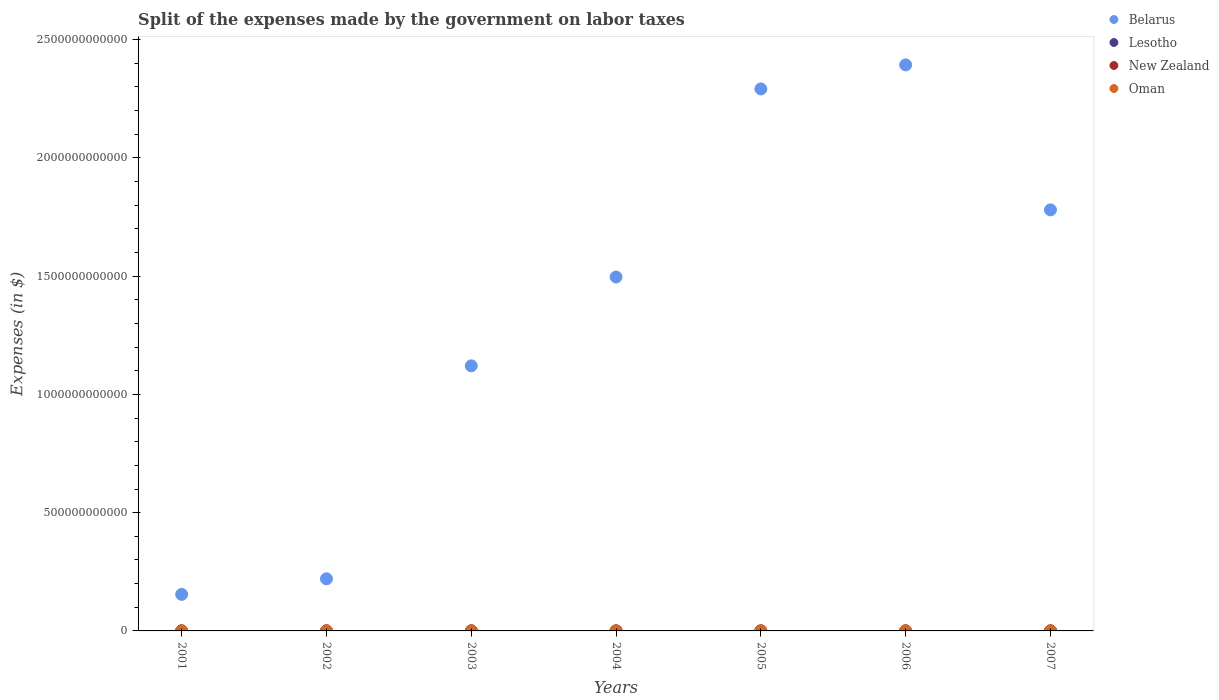How many different coloured dotlines are there?
Provide a short and direct response. 4. What is the expenses made by the government on labor taxes in Oman in 2005?
Provide a succinct answer. 7.12e+07. Across all years, what is the maximum expenses made by the government on labor taxes in Belarus?
Give a very brief answer. 2.39e+12. Across all years, what is the minimum expenses made by the government on labor taxes in Oman?
Your answer should be very brief. 3.87e+07. In which year was the expenses made by the government on labor taxes in New Zealand maximum?
Provide a short and direct response. 2006. In which year was the expenses made by the government on labor taxes in Belarus minimum?
Ensure brevity in your answer.  2001. What is the total expenses made by the government on labor taxes in Belarus in the graph?
Make the answer very short. 9.46e+12. What is the difference between the expenses made by the government on labor taxes in New Zealand in 2002 and that in 2004?
Give a very brief answer. -1.04e+06. What is the difference between the expenses made by the government on labor taxes in New Zealand in 2006 and the expenses made by the government on labor taxes in Lesotho in 2004?
Ensure brevity in your answer.  -1.48e+07. What is the average expenses made by the government on labor taxes in Oman per year?
Provide a short and direct response. 5.87e+07. In the year 2003, what is the difference between the expenses made by the government on labor taxes in Oman and expenses made by the government on labor taxes in Belarus?
Your response must be concise. -1.12e+12. What is the ratio of the expenses made by the government on labor taxes in Belarus in 2001 to that in 2007?
Your answer should be very brief. 0.09. Is the expenses made by the government on labor taxes in Belarus in 2001 less than that in 2004?
Provide a succinct answer. Yes. What is the difference between the highest and the second highest expenses made by the government on labor taxes in New Zealand?
Your answer should be very brief. 6.51e+05. What is the difference between the highest and the lowest expenses made by the government on labor taxes in Belarus?
Your answer should be very brief. 2.24e+12. In how many years, is the expenses made by the government on labor taxes in New Zealand greater than the average expenses made by the government on labor taxes in New Zealand taken over all years?
Provide a succinct answer. 3. Is it the case that in every year, the sum of the expenses made by the government on labor taxes in Belarus and expenses made by the government on labor taxes in New Zealand  is greater than the sum of expenses made by the government on labor taxes in Lesotho and expenses made by the government on labor taxes in Oman?
Offer a terse response. No. Is it the case that in every year, the sum of the expenses made by the government on labor taxes in Lesotho and expenses made by the government on labor taxes in Belarus  is greater than the expenses made by the government on labor taxes in New Zealand?
Make the answer very short. Yes. How many years are there in the graph?
Provide a short and direct response. 7. What is the difference between two consecutive major ticks on the Y-axis?
Offer a very short reply. 5.00e+11. Does the graph contain any zero values?
Make the answer very short. No. Does the graph contain grids?
Your response must be concise. No. What is the title of the graph?
Your answer should be very brief. Split of the expenses made by the government on labor taxes. What is the label or title of the X-axis?
Keep it short and to the point. Years. What is the label or title of the Y-axis?
Make the answer very short. Expenses (in $). What is the Expenses (in $) of Belarus in 2001?
Offer a terse response. 1.55e+11. What is the Expenses (in $) in Lesotho in 2001?
Your answer should be very brief. 5.30e+06. What is the Expenses (in $) in New Zealand in 2001?
Offer a terse response. 1.80e+06. What is the Expenses (in $) in Oman in 2001?
Offer a terse response. 3.87e+07. What is the Expenses (in $) of Belarus in 2002?
Offer a very short reply. 2.20e+11. What is the Expenses (in $) of Lesotho in 2002?
Make the answer very short. 6.40e+06. What is the Expenses (in $) in New Zealand in 2002?
Offer a terse response. 1.31e+06. What is the Expenses (in $) of Oman in 2002?
Provide a succinct answer. 3.98e+07. What is the Expenses (in $) of Belarus in 2003?
Your response must be concise. 1.12e+12. What is the Expenses (in $) of Lesotho in 2003?
Offer a very short reply. 1.05e+07. What is the Expenses (in $) in New Zealand in 2003?
Your answer should be compact. 1.36e+06. What is the Expenses (in $) in Oman in 2003?
Make the answer very short. 4.31e+07. What is the Expenses (in $) in Belarus in 2004?
Offer a terse response. 1.50e+12. What is the Expenses (in $) of Lesotho in 2004?
Provide a short and direct response. 1.78e+07. What is the Expenses (in $) of New Zealand in 2004?
Make the answer very short. 2.35e+06. What is the Expenses (in $) of Oman in 2004?
Offer a very short reply. 4.91e+07. What is the Expenses (in $) of Belarus in 2005?
Give a very brief answer. 2.29e+12. What is the Expenses (in $) in Lesotho in 2005?
Keep it short and to the point. 6.74e+06. What is the Expenses (in $) in New Zealand in 2005?
Offer a very short reply. 2.32e+06. What is the Expenses (in $) of Oman in 2005?
Your response must be concise. 7.12e+07. What is the Expenses (in $) of Belarus in 2006?
Keep it short and to the point. 2.39e+12. What is the Expenses (in $) in Lesotho in 2006?
Make the answer very short. 7.48e+07. What is the Expenses (in $) in Oman in 2006?
Provide a short and direct response. 7.82e+07. What is the Expenses (in $) in Belarus in 2007?
Ensure brevity in your answer.  1.78e+12. What is the Expenses (in $) in Lesotho in 2007?
Provide a short and direct response. 6.62e+06. What is the Expenses (in $) in Oman in 2007?
Offer a terse response. 9.09e+07. Across all years, what is the maximum Expenses (in $) of Belarus?
Provide a succinct answer. 2.39e+12. Across all years, what is the maximum Expenses (in $) of Lesotho?
Your answer should be compact. 7.48e+07. Across all years, what is the maximum Expenses (in $) in Oman?
Offer a very short reply. 9.09e+07. Across all years, what is the minimum Expenses (in $) in Belarus?
Make the answer very short. 1.55e+11. Across all years, what is the minimum Expenses (in $) in Lesotho?
Provide a succinct answer. 5.30e+06. Across all years, what is the minimum Expenses (in $) of New Zealand?
Offer a terse response. 1.31e+06. Across all years, what is the minimum Expenses (in $) in Oman?
Make the answer very short. 3.87e+07. What is the total Expenses (in $) of Belarus in the graph?
Offer a terse response. 9.46e+12. What is the total Expenses (in $) in Lesotho in the graph?
Your answer should be very brief. 1.28e+08. What is the total Expenses (in $) in New Zealand in the graph?
Keep it short and to the point. 1.41e+07. What is the total Expenses (in $) of Oman in the graph?
Offer a terse response. 4.11e+08. What is the difference between the Expenses (in $) in Belarus in 2001 and that in 2002?
Your response must be concise. -6.58e+1. What is the difference between the Expenses (in $) of Lesotho in 2001 and that in 2002?
Give a very brief answer. -1.10e+06. What is the difference between the Expenses (in $) of New Zealand in 2001 and that in 2002?
Keep it short and to the point. 4.87e+05. What is the difference between the Expenses (in $) of Oman in 2001 and that in 2002?
Provide a succinct answer. -1.10e+06. What is the difference between the Expenses (in $) of Belarus in 2001 and that in 2003?
Your answer should be very brief. -9.66e+11. What is the difference between the Expenses (in $) of Lesotho in 2001 and that in 2003?
Offer a very short reply. -5.18e+06. What is the difference between the Expenses (in $) in New Zealand in 2001 and that in 2003?
Provide a succinct answer. 4.44e+05. What is the difference between the Expenses (in $) of Oman in 2001 and that in 2003?
Your answer should be compact. -4.40e+06. What is the difference between the Expenses (in $) in Belarus in 2001 and that in 2004?
Your response must be concise. -1.34e+12. What is the difference between the Expenses (in $) of Lesotho in 2001 and that in 2004?
Your answer should be very brief. -1.25e+07. What is the difference between the Expenses (in $) of New Zealand in 2001 and that in 2004?
Offer a very short reply. -5.49e+05. What is the difference between the Expenses (in $) in Oman in 2001 and that in 2004?
Provide a succinct answer. -1.04e+07. What is the difference between the Expenses (in $) in Belarus in 2001 and that in 2005?
Your response must be concise. -2.14e+12. What is the difference between the Expenses (in $) of Lesotho in 2001 and that in 2005?
Keep it short and to the point. -1.44e+06. What is the difference between the Expenses (in $) in New Zealand in 2001 and that in 2005?
Provide a short and direct response. -5.25e+05. What is the difference between the Expenses (in $) of Oman in 2001 and that in 2005?
Your answer should be compact. -3.25e+07. What is the difference between the Expenses (in $) of Belarus in 2001 and that in 2006?
Offer a terse response. -2.24e+12. What is the difference between the Expenses (in $) of Lesotho in 2001 and that in 2006?
Your answer should be compact. -6.95e+07. What is the difference between the Expenses (in $) of New Zealand in 2001 and that in 2006?
Provide a short and direct response. -1.20e+06. What is the difference between the Expenses (in $) in Oman in 2001 and that in 2006?
Offer a very short reply. -3.95e+07. What is the difference between the Expenses (in $) of Belarus in 2001 and that in 2007?
Make the answer very short. -1.63e+12. What is the difference between the Expenses (in $) in Lesotho in 2001 and that in 2007?
Provide a short and direct response. -1.32e+06. What is the difference between the Expenses (in $) in New Zealand in 2001 and that in 2007?
Keep it short and to the point. -2.00e+05. What is the difference between the Expenses (in $) in Oman in 2001 and that in 2007?
Your answer should be very brief. -5.22e+07. What is the difference between the Expenses (in $) in Belarus in 2002 and that in 2003?
Make the answer very short. -9.00e+11. What is the difference between the Expenses (in $) of Lesotho in 2002 and that in 2003?
Your response must be concise. -4.08e+06. What is the difference between the Expenses (in $) in New Zealand in 2002 and that in 2003?
Provide a short and direct response. -4.30e+04. What is the difference between the Expenses (in $) in Oman in 2002 and that in 2003?
Ensure brevity in your answer.  -3.30e+06. What is the difference between the Expenses (in $) of Belarus in 2002 and that in 2004?
Give a very brief answer. -1.28e+12. What is the difference between the Expenses (in $) of Lesotho in 2002 and that in 2004?
Offer a very short reply. -1.14e+07. What is the difference between the Expenses (in $) in New Zealand in 2002 and that in 2004?
Your answer should be compact. -1.04e+06. What is the difference between the Expenses (in $) in Oman in 2002 and that in 2004?
Offer a very short reply. -9.30e+06. What is the difference between the Expenses (in $) in Belarus in 2002 and that in 2005?
Ensure brevity in your answer.  -2.07e+12. What is the difference between the Expenses (in $) in Lesotho in 2002 and that in 2005?
Your response must be concise. -3.35e+05. What is the difference between the Expenses (in $) of New Zealand in 2002 and that in 2005?
Offer a terse response. -1.01e+06. What is the difference between the Expenses (in $) of Oman in 2002 and that in 2005?
Your answer should be compact. -3.14e+07. What is the difference between the Expenses (in $) of Belarus in 2002 and that in 2006?
Your answer should be compact. -2.17e+12. What is the difference between the Expenses (in $) of Lesotho in 2002 and that in 2006?
Ensure brevity in your answer.  -6.84e+07. What is the difference between the Expenses (in $) in New Zealand in 2002 and that in 2006?
Offer a terse response. -1.69e+06. What is the difference between the Expenses (in $) in Oman in 2002 and that in 2006?
Offer a terse response. -3.84e+07. What is the difference between the Expenses (in $) of Belarus in 2002 and that in 2007?
Keep it short and to the point. -1.56e+12. What is the difference between the Expenses (in $) in Lesotho in 2002 and that in 2007?
Offer a very short reply. -2.19e+05. What is the difference between the Expenses (in $) in New Zealand in 2002 and that in 2007?
Ensure brevity in your answer.  -6.87e+05. What is the difference between the Expenses (in $) in Oman in 2002 and that in 2007?
Offer a terse response. -5.11e+07. What is the difference between the Expenses (in $) in Belarus in 2003 and that in 2004?
Your response must be concise. -3.75e+11. What is the difference between the Expenses (in $) of Lesotho in 2003 and that in 2004?
Your response must be concise. -7.32e+06. What is the difference between the Expenses (in $) in New Zealand in 2003 and that in 2004?
Provide a succinct answer. -9.93e+05. What is the difference between the Expenses (in $) of Oman in 2003 and that in 2004?
Offer a terse response. -6.00e+06. What is the difference between the Expenses (in $) in Belarus in 2003 and that in 2005?
Your answer should be compact. -1.17e+12. What is the difference between the Expenses (in $) in Lesotho in 2003 and that in 2005?
Ensure brevity in your answer.  3.74e+06. What is the difference between the Expenses (in $) of New Zealand in 2003 and that in 2005?
Your response must be concise. -9.69e+05. What is the difference between the Expenses (in $) of Oman in 2003 and that in 2005?
Your answer should be very brief. -2.81e+07. What is the difference between the Expenses (in $) in Belarus in 2003 and that in 2006?
Give a very brief answer. -1.27e+12. What is the difference between the Expenses (in $) of Lesotho in 2003 and that in 2006?
Provide a succinct answer. -6.43e+07. What is the difference between the Expenses (in $) of New Zealand in 2003 and that in 2006?
Your response must be concise. -1.64e+06. What is the difference between the Expenses (in $) in Oman in 2003 and that in 2006?
Provide a succinct answer. -3.51e+07. What is the difference between the Expenses (in $) in Belarus in 2003 and that in 2007?
Ensure brevity in your answer.  -6.59e+11. What is the difference between the Expenses (in $) in Lesotho in 2003 and that in 2007?
Your answer should be very brief. 3.86e+06. What is the difference between the Expenses (in $) of New Zealand in 2003 and that in 2007?
Give a very brief answer. -6.44e+05. What is the difference between the Expenses (in $) in Oman in 2003 and that in 2007?
Your response must be concise. -4.78e+07. What is the difference between the Expenses (in $) of Belarus in 2004 and that in 2005?
Your answer should be very brief. -7.95e+11. What is the difference between the Expenses (in $) of Lesotho in 2004 and that in 2005?
Your answer should be very brief. 1.11e+07. What is the difference between the Expenses (in $) of New Zealand in 2004 and that in 2005?
Give a very brief answer. 2.40e+04. What is the difference between the Expenses (in $) of Oman in 2004 and that in 2005?
Provide a short and direct response. -2.21e+07. What is the difference between the Expenses (in $) in Belarus in 2004 and that in 2006?
Offer a very short reply. -8.97e+11. What is the difference between the Expenses (in $) in Lesotho in 2004 and that in 2006?
Your answer should be very brief. -5.70e+07. What is the difference between the Expenses (in $) of New Zealand in 2004 and that in 2006?
Give a very brief answer. -6.51e+05. What is the difference between the Expenses (in $) of Oman in 2004 and that in 2006?
Keep it short and to the point. -2.91e+07. What is the difference between the Expenses (in $) of Belarus in 2004 and that in 2007?
Offer a very short reply. -2.84e+11. What is the difference between the Expenses (in $) of Lesotho in 2004 and that in 2007?
Offer a very short reply. 1.12e+07. What is the difference between the Expenses (in $) of New Zealand in 2004 and that in 2007?
Your answer should be very brief. 3.49e+05. What is the difference between the Expenses (in $) of Oman in 2004 and that in 2007?
Provide a succinct answer. -4.18e+07. What is the difference between the Expenses (in $) in Belarus in 2005 and that in 2006?
Provide a succinct answer. -1.02e+11. What is the difference between the Expenses (in $) in Lesotho in 2005 and that in 2006?
Make the answer very short. -6.81e+07. What is the difference between the Expenses (in $) of New Zealand in 2005 and that in 2006?
Your response must be concise. -6.75e+05. What is the difference between the Expenses (in $) in Oman in 2005 and that in 2006?
Your answer should be very brief. -7.00e+06. What is the difference between the Expenses (in $) in Belarus in 2005 and that in 2007?
Ensure brevity in your answer.  5.11e+11. What is the difference between the Expenses (in $) of Lesotho in 2005 and that in 2007?
Provide a short and direct response. 1.16e+05. What is the difference between the Expenses (in $) of New Zealand in 2005 and that in 2007?
Ensure brevity in your answer.  3.25e+05. What is the difference between the Expenses (in $) of Oman in 2005 and that in 2007?
Your response must be concise. -1.97e+07. What is the difference between the Expenses (in $) in Belarus in 2006 and that in 2007?
Your response must be concise. 6.13e+11. What is the difference between the Expenses (in $) in Lesotho in 2006 and that in 2007?
Your response must be concise. 6.82e+07. What is the difference between the Expenses (in $) in Oman in 2006 and that in 2007?
Your answer should be compact. -1.27e+07. What is the difference between the Expenses (in $) of Belarus in 2001 and the Expenses (in $) of Lesotho in 2002?
Offer a very short reply. 1.55e+11. What is the difference between the Expenses (in $) in Belarus in 2001 and the Expenses (in $) in New Zealand in 2002?
Offer a terse response. 1.55e+11. What is the difference between the Expenses (in $) of Belarus in 2001 and the Expenses (in $) of Oman in 2002?
Provide a short and direct response. 1.55e+11. What is the difference between the Expenses (in $) in Lesotho in 2001 and the Expenses (in $) in New Zealand in 2002?
Give a very brief answer. 3.99e+06. What is the difference between the Expenses (in $) of Lesotho in 2001 and the Expenses (in $) of Oman in 2002?
Ensure brevity in your answer.  -3.45e+07. What is the difference between the Expenses (in $) in New Zealand in 2001 and the Expenses (in $) in Oman in 2002?
Make the answer very short. -3.80e+07. What is the difference between the Expenses (in $) in Belarus in 2001 and the Expenses (in $) in Lesotho in 2003?
Your answer should be very brief. 1.55e+11. What is the difference between the Expenses (in $) in Belarus in 2001 and the Expenses (in $) in New Zealand in 2003?
Ensure brevity in your answer.  1.55e+11. What is the difference between the Expenses (in $) in Belarus in 2001 and the Expenses (in $) in Oman in 2003?
Offer a terse response. 1.54e+11. What is the difference between the Expenses (in $) in Lesotho in 2001 and the Expenses (in $) in New Zealand in 2003?
Your answer should be very brief. 3.94e+06. What is the difference between the Expenses (in $) in Lesotho in 2001 and the Expenses (in $) in Oman in 2003?
Your answer should be very brief. -3.78e+07. What is the difference between the Expenses (in $) in New Zealand in 2001 and the Expenses (in $) in Oman in 2003?
Offer a very short reply. -4.13e+07. What is the difference between the Expenses (in $) in Belarus in 2001 and the Expenses (in $) in Lesotho in 2004?
Give a very brief answer. 1.55e+11. What is the difference between the Expenses (in $) of Belarus in 2001 and the Expenses (in $) of New Zealand in 2004?
Make the answer very short. 1.55e+11. What is the difference between the Expenses (in $) in Belarus in 2001 and the Expenses (in $) in Oman in 2004?
Your response must be concise. 1.54e+11. What is the difference between the Expenses (in $) of Lesotho in 2001 and the Expenses (in $) of New Zealand in 2004?
Your response must be concise. 2.95e+06. What is the difference between the Expenses (in $) in Lesotho in 2001 and the Expenses (in $) in Oman in 2004?
Give a very brief answer. -4.38e+07. What is the difference between the Expenses (in $) of New Zealand in 2001 and the Expenses (in $) of Oman in 2004?
Keep it short and to the point. -4.73e+07. What is the difference between the Expenses (in $) of Belarus in 2001 and the Expenses (in $) of Lesotho in 2005?
Your answer should be very brief. 1.55e+11. What is the difference between the Expenses (in $) in Belarus in 2001 and the Expenses (in $) in New Zealand in 2005?
Offer a very short reply. 1.55e+11. What is the difference between the Expenses (in $) of Belarus in 2001 and the Expenses (in $) of Oman in 2005?
Make the answer very short. 1.54e+11. What is the difference between the Expenses (in $) of Lesotho in 2001 and the Expenses (in $) of New Zealand in 2005?
Give a very brief answer. 2.98e+06. What is the difference between the Expenses (in $) of Lesotho in 2001 and the Expenses (in $) of Oman in 2005?
Provide a succinct answer. -6.59e+07. What is the difference between the Expenses (in $) of New Zealand in 2001 and the Expenses (in $) of Oman in 2005?
Provide a succinct answer. -6.94e+07. What is the difference between the Expenses (in $) in Belarus in 2001 and the Expenses (in $) in Lesotho in 2006?
Your response must be concise. 1.54e+11. What is the difference between the Expenses (in $) in Belarus in 2001 and the Expenses (in $) in New Zealand in 2006?
Offer a terse response. 1.55e+11. What is the difference between the Expenses (in $) of Belarus in 2001 and the Expenses (in $) of Oman in 2006?
Offer a very short reply. 1.54e+11. What is the difference between the Expenses (in $) of Lesotho in 2001 and the Expenses (in $) of New Zealand in 2006?
Offer a terse response. 2.30e+06. What is the difference between the Expenses (in $) of Lesotho in 2001 and the Expenses (in $) of Oman in 2006?
Ensure brevity in your answer.  -7.29e+07. What is the difference between the Expenses (in $) of New Zealand in 2001 and the Expenses (in $) of Oman in 2006?
Offer a terse response. -7.64e+07. What is the difference between the Expenses (in $) in Belarus in 2001 and the Expenses (in $) in Lesotho in 2007?
Provide a succinct answer. 1.55e+11. What is the difference between the Expenses (in $) in Belarus in 2001 and the Expenses (in $) in New Zealand in 2007?
Your answer should be very brief. 1.55e+11. What is the difference between the Expenses (in $) of Belarus in 2001 and the Expenses (in $) of Oman in 2007?
Make the answer very short. 1.54e+11. What is the difference between the Expenses (in $) of Lesotho in 2001 and the Expenses (in $) of New Zealand in 2007?
Your response must be concise. 3.30e+06. What is the difference between the Expenses (in $) in Lesotho in 2001 and the Expenses (in $) in Oman in 2007?
Ensure brevity in your answer.  -8.56e+07. What is the difference between the Expenses (in $) in New Zealand in 2001 and the Expenses (in $) in Oman in 2007?
Offer a terse response. -8.91e+07. What is the difference between the Expenses (in $) of Belarus in 2002 and the Expenses (in $) of Lesotho in 2003?
Provide a succinct answer. 2.20e+11. What is the difference between the Expenses (in $) in Belarus in 2002 and the Expenses (in $) in New Zealand in 2003?
Make the answer very short. 2.20e+11. What is the difference between the Expenses (in $) in Belarus in 2002 and the Expenses (in $) in Oman in 2003?
Offer a very short reply. 2.20e+11. What is the difference between the Expenses (in $) in Lesotho in 2002 and the Expenses (in $) in New Zealand in 2003?
Your response must be concise. 5.04e+06. What is the difference between the Expenses (in $) in Lesotho in 2002 and the Expenses (in $) in Oman in 2003?
Make the answer very short. -3.67e+07. What is the difference between the Expenses (in $) in New Zealand in 2002 and the Expenses (in $) in Oman in 2003?
Offer a terse response. -4.18e+07. What is the difference between the Expenses (in $) of Belarus in 2002 and the Expenses (in $) of Lesotho in 2004?
Offer a terse response. 2.20e+11. What is the difference between the Expenses (in $) of Belarus in 2002 and the Expenses (in $) of New Zealand in 2004?
Offer a terse response. 2.20e+11. What is the difference between the Expenses (in $) in Belarus in 2002 and the Expenses (in $) in Oman in 2004?
Give a very brief answer. 2.20e+11. What is the difference between the Expenses (in $) in Lesotho in 2002 and the Expenses (in $) in New Zealand in 2004?
Your answer should be very brief. 4.05e+06. What is the difference between the Expenses (in $) of Lesotho in 2002 and the Expenses (in $) of Oman in 2004?
Your answer should be compact. -4.27e+07. What is the difference between the Expenses (in $) of New Zealand in 2002 and the Expenses (in $) of Oman in 2004?
Your answer should be very brief. -4.78e+07. What is the difference between the Expenses (in $) of Belarus in 2002 and the Expenses (in $) of Lesotho in 2005?
Give a very brief answer. 2.20e+11. What is the difference between the Expenses (in $) of Belarus in 2002 and the Expenses (in $) of New Zealand in 2005?
Provide a succinct answer. 2.20e+11. What is the difference between the Expenses (in $) of Belarus in 2002 and the Expenses (in $) of Oman in 2005?
Offer a terse response. 2.20e+11. What is the difference between the Expenses (in $) of Lesotho in 2002 and the Expenses (in $) of New Zealand in 2005?
Give a very brief answer. 4.08e+06. What is the difference between the Expenses (in $) of Lesotho in 2002 and the Expenses (in $) of Oman in 2005?
Make the answer very short. -6.48e+07. What is the difference between the Expenses (in $) in New Zealand in 2002 and the Expenses (in $) in Oman in 2005?
Your answer should be compact. -6.99e+07. What is the difference between the Expenses (in $) of Belarus in 2002 and the Expenses (in $) of Lesotho in 2006?
Your answer should be very brief. 2.20e+11. What is the difference between the Expenses (in $) of Belarus in 2002 and the Expenses (in $) of New Zealand in 2006?
Your response must be concise. 2.20e+11. What is the difference between the Expenses (in $) of Belarus in 2002 and the Expenses (in $) of Oman in 2006?
Offer a very short reply. 2.20e+11. What is the difference between the Expenses (in $) of Lesotho in 2002 and the Expenses (in $) of New Zealand in 2006?
Give a very brief answer. 3.40e+06. What is the difference between the Expenses (in $) in Lesotho in 2002 and the Expenses (in $) in Oman in 2006?
Provide a succinct answer. -7.18e+07. What is the difference between the Expenses (in $) of New Zealand in 2002 and the Expenses (in $) of Oman in 2006?
Keep it short and to the point. -7.69e+07. What is the difference between the Expenses (in $) of Belarus in 2002 and the Expenses (in $) of Lesotho in 2007?
Offer a terse response. 2.20e+11. What is the difference between the Expenses (in $) of Belarus in 2002 and the Expenses (in $) of New Zealand in 2007?
Offer a very short reply. 2.20e+11. What is the difference between the Expenses (in $) of Belarus in 2002 and the Expenses (in $) of Oman in 2007?
Your answer should be very brief. 2.20e+11. What is the difference between the Expenses (in $) in Lesotho in 2002 and the Expenses (in $) in New Zealand in 2007?
Offer a terse response. 4.40e+06. What is the difference between the Expenses (in $) in Lesotho in 2002 and the Expenses (in $) in Oman in 2007?
Your answer should be very brief. -8.45e+07. What is the difference between the Expenses (in $) in New Zealand in 2002 and the Expenses (in $) in Oman in 2007?
Your response must be concise. -8.96e+07. What is the difference between the Expenses (in $) of Belarus in 2003 and the Expenses (in $) of Lesotho in 2004?
Provide a succinct answer. 1.12e+12. What is the difference between the Expenses (in $) in Belarus in 2003 and the Expenses (in $) in New Zealand in 2004?
Make the answer very short. 1.12e+12. What is the difference between the Expenses (in $) in Belarus in 2003 and the Expenses (in $) in Oman in 2004?
Make the answer very short. 1.12e+12. What is the difference between the Expenses (in $) in Lesotho in 2003 and the Expenses (in $) in New Zealand in 2004?
Offer a very short reply. 8.13e+06. What is the difference between the Expenses (in $) in Lesotho in 2003 and the Expenses (in $) in Oman in 2004?
Your answer should be very brief. -3.86e+07. What is the difference between the Expenses (in $) in New Zealand in 2003 and the Expenses (in $) in Oman in 2004?
Your answer should be compact. -4.77e+07. What is the difference between the Expenses (in $) of Belarus in 2003 and the Expenses (in $) of Lesotho in 2005?
Your answer should be compact. 1.12e+12. What is the difference between the Expenses (in $) in Belarus in 2003 and the Expenses (in $) in New Zealand in 2005?
Provide a short and direct response. 1.12e+12. What is the difference between the Expenses (in $) in Belarus in 2003 and the Expenses (in $) in Oman in 2005?
Provide a succinct answer. 1.12e+12. What is the difference between the Expenses (in $) in Lesotho in 2003 and the Expenses (in $) in New Zealand in 2005?
Offer a terse response. 8.15e+06. What is the difference between the Expenses (in $) in Lesotho in 2003 and the Expenses (in $) in Oman in 2005?
Provide a short and direct response. -6.07e+07. What is the difference between the Expenses (in $) in New Zealand in 2003 and the Expenses (in $) in Oman in 2005?
Offer a terse response. -6.98e+07. What is the difference between the Expenses (in $) in Belarus in 2003 and the Expenses (in $) in Lesotho in 2006?
Keep it short and to the point. 1.12e+12. What is the difference between the Expenses (in $) in Belarus in 2003 and the Expenses (in $) in New Zealand in 2006?
Give a very brief answer. 1.12e+12. What is the difference between the Expenses (in $) of Belarus in 2003 and the Expenses (in $) of Oman in 2006?
Make the answer very short. 1.12e+12. What is the difference between the Expenses (in $) in Lesotho in 2003 and the Expenses (in $) in New Zealand in 2006?
Your answer should be very brief. 7.48e+06. What is the difference between the Expenses (in $) of Lesotho in 2003 and the Expenses (in $) of Oman in 2006?
Provide a succinct answer. -6.77e+07. What is the difference between the Expenses (in $) of New Zealand in 2003 and the Expenses (in $) of Oman in 2006?
Give a very brief answer. -7.68e+07. What is the difference between the Expenses (in $) in Belarus in 2003 and the Expenses (in $) in Lesotho in 2007?
Your response must be concise. 1.12e+12. What is the difference between the Expenses (in $) in Belarus in 2003 and the Expenses (in $) in New Zealand in 2007?
Give a very brief answer. 1.12e+12. What is the difference between the Expenses (in $) of Belarus in 2003 and the Expenses (in $) of Oman in 2007?
Make the answer very short. 1.12e+12. What is the difference between the Expenses (in $) of Lesotho in 2003 and the Expenses (in $) of New Zealand in 2007?
Ensure brevity in your answer.  8.48e+06. What is the difference between the Expenses (in $) in Lesotho in 2003 and the Expenses (in $) in Oman in 2007?
Make the answer very short. -8.04e+07. What is the difference between the Expenses (in $) of New Zealand in 2003 and the Expenses (in $) of Oman in 2007?
Make the answer very short. -8.95e+07. What is the difference between the Expenses (in $) of Belarus in 2004 and the Expenses (in $) of Lesotho in 2005?
Provide a short and direct response. 1.50e+12. What is the difference between the Expenses (in $) of Belarus in 2004 and the Expenses (in $) of New Zealand in 2005?
Keep it short and to the point. 1.50e+12. What is the difference between the Expenses (in $) of Belarus in 2004 and the Expenses (in $) of Oman in 2005?
Ensure brevity in your answer.  1.50e+12. What is the difference between the Expenses (in $) of Lesotho in 2004 and the Expenses (in $) of New Zealand in 2005?
Ensure brevity in your answer.  1.55e+07. What is the difference between the Expenses (in $) in Lesotho in 2004 and the Expenses (in $) in Oman in 2005?
Your answer should be compact. -5.34e+07. What is the difference between the Expenses (in $) in New Zealand in 2004 and the Expenses (in $) in Oman in 2005?
Your answer should be compact. -6.89e+07. What is the difference between the Expenses (in $) of Belarus in 2004 and the Expenses (in $) of Lesotho in 2006?
Keep it short and to the point. 1.50e+12. What is the difference between the Expenses (in $) in Belarus in 2004 and the Expenses (in $) in New Zealand in 2006?
Offer a terse response. 1.50e+12. What is the difference between the Expenses (in $) of Belarus in 2004 and the Expenses (in $) of Oman in 2006?
Ensure brevity in your answer.  1.50e+12. What is the difference between the Expenses (in $) of Lesotho in 2004 and the Expenses (in $) of New Zealand in 2006?
Your answer should be compact. 1.48e+07. What is the difference between the Expenses (in $) of Lesotho in 2004 and the Expenses (in $) of Oman in 2006?
Provide a succinct answer. -6.04e+07. What is the difference between the Expenses (in $) of New Zealand in 2004 and the Expenses (in $) of Oman in 2006?
Provide a short and direct response. -7.59e+07. What is the difference between the Expenses (in $) of Belarus in 2004 and the Expenses (in $) of Lesotho in 2007?
Make the answer very short. 1.50e+12. What is the difference between the Expenses (in $) in Belarus in 2004 and the Expenses (in $) in New Zealand in 2007?
Offer a terse response. 1.50e+12. What is the difference between the Expenses (in $) of Belarus in 2004 and the Expenses (in $) of Oman in 2007?
Ensure brevity in your answer.  1.50e+12. What is the difference between the Expenses (in $) in Lesotho in 2004 and the Expenses (in $) in New Zealand in 2007?
Make the answer very short. 1.58e+07. What is the difference between the Expenses (in $) of Lesotho in 2004 and the Expenses (in $) of Oman in 2007?
Provide a short and direct response. -7.31e+07. What is the difference between the Expenses (in $) in New Zealand in 2004 and the Expenses (in $) in Oman in 2007?
Your answer should be very brief. -8.86e+07. What is the difference between the Expenses (in $) of Belarus in 2005 and the Expenses (in $) of Lesotho in 2006?
Your answer should be very brief. 2.29e+12. What is the difference between the Expenses (in $) in Belarus in 2005 and the Expenses (in $) in New Zealand in 2006?
Your response must be concise. 2.29e+12. What is the difference between the Expenses (in $) in Belarus in 2005 and the Expenses (in $) in Oman in 2006?
Offer a very short reply. 2.29e+12. What is the difference between the Expenses (in $) of Lesotho in 2005 and the Expenses (in $) of New Zealand in 2006?
Offer a very short reply. 3.74e+06. What is the difference between the Expenses (in $) of Lesotho in 2005 and the Expenses (in $) of Oman in 2006?
Your response must be concise. -7.15e+07. What is the difference between the Expenses (in $) in New Zealand in 2005 and the Expenses (in $) in Oman in 2006?
Offer a very short reply. -7.59e+07. What is the difference between the Expenses (in $) in Belarus in 2005 and the Expenses (in $) in Lesotho in 2007?
Your response must be concise. 2.29e+12. What is the difference between the Expenses (in $) of Belarus in 2005 and the Expenses (in $) of New Zealand in 2007?
Your answer should be very brief. 2.29e+12. What is the difference between the Expenses (in $) in Belarus in 2005 and the Expenses (in $) in Oman in 2007?
Your answer should be compact. 2.29e+12. What is the difference between the Expenses (in $) of Lesotho in 2005 and the Expenses (in $) of New Zealand in 2007?
Provide a succinct answer. 4.74e+06. What is the difference between the Expenses (in $) of Lesotho in 2005 and the Expenses (in $) of Oman in 2007?
Your response must be concise. -8.42e+07. What is the difference between the Expenses (in $) in New Zealand in 2005 and the Expenses (in $) in Oman in 2007?
Offer a very short reply. -8.86e+07. What is the difference between the Expenses (in $) of Belarus in 2006 and the Expenses (in $) of Lesotho in 2007?
Offer a very short reply. 2.39e+12. What is the difference between the Expenses (in $) in Belarus in 2006 and the Expenses (in $) in New Zealand in 2007?
Offer a terse response. 2.39e+12. What is the difference between the Expenses (in $) of Belarus in 2006 and the Expenses (in $) of Oman in 2007?
Offer a very short reply. 2.39e+12. What is the difference between the Expenses (in $) of Lesotho in 2006 and the Expenses (in $) of New Zealand in 2007?
Ensure brevity in your answer.  7.28e+07. What is the difference between the Expenses (in $) of Lesotho in 2006 and the Expenses (in $) of Oman in 2007?
Give a very brief answer. -1.61e+07. What is the difference between the Expenses (in $) of New Zealand in 2006 and the Expenses (in $) of Oman in 2007?
Your response must be concise. -8.79e+07. What is the average Expenses (in $) in Belarus per year?
Make the answer very short. 1.35e+12. What is the average Expenses (in $) in Lesotho per year?
Keep it short and to the point. 1.83e+07. What is the average Expenses (in $) in New Zealand per year?
Ensure brevity in your answer.  2.02e+06. What is the average Expenses (in $) of Oman per year?
Offer a very short reply. 5.87e+07. In the year 2001, what is the difference between the Expenses (in $) in Belarus and Expenses (in $) in Lesotho?
Your answer should be very brief. 1.55e+11. In the year 2001, what is the difference between the Expenses (in $) of Belarus and Expenses (in $) of New Zealand?
Your answer should be compact. 1.55e+11. In the year 2001, what is the difference between the Expenses (in $) in Belarus and Expenses (in $) in Oman?
Offer a terse response. 1.55e+11. In the year 2001, what is the difference between the Expenses (in $) of Lesotho and Expenses (in $) of New Zealand?
Your response must be concise. 3.50e+06. In the year 2001, what is the difference between the Expenses (in $) of Lesotho and Expenses (in $) of Oman?
Your answer should be compact. -3.34e+07. In the year 2001, what is the difference between the Expenses (in $) in New Zealand and Expenses (in $) in Oman?
Ensure brevity in your answer.  -3.69e+07. In the year 2002, what is the difference between the Expenses (in $) in Belarus and Expenses (in $) in Lesotho?
Ensure brevity in your answer.  2.20e+11. In the year 2002, what is the difference between the Expenses (in $) in Belarus and Expenses (in $) in New Zealand?
Give a very brief answer. 2.20e+11. In the year 2002, what is the difference between the Expenses (in $) in Belarus and Expenses (in $) in Oman?
Your response must be concise. 2.20e+11. In the year 2002, what is the difference between the Expenses (in $) in Lesotho and Expenses (in $) in New Zealand?
Provide a short and direct response. 5.09e+06. In the year 2002, what is the difference between the Expenses (in $) in Lesotho and Expenses (in $) in Oman?
Offer a very short reply. -3.34e+07. In the year 2002, what is the difference between the Expenses (in $) in New Zealand and Expenses (in $) in Oman?
Provide a short and direct response. -3.85e+07. In the year 2003, what is the difference between the Expenses (in $) in Belarus and Expenses (in $) in Lesotho?
Provide a succinct answer. 1.12e+12. In the year 2003, what is the difference between the Expenses (in $) of Belarus and Expenses (in $) of New Zealand?
Ensure brevity in your answer.  1.12e+12. In the year 2003, what is the difference between the Expenses (in $) of Belarus and Expenses (in $) of Oman?
Keep it short and to the point. 1.12e+12. In the year 2003, what is the difference between the Expenses (in $) in Lesotho and Expenses (in $) in New Zealand?
Your answer should be compact. 9.12e+06. In the year 2003, what is the difference between the Expenses (in $) of Lesotho and Expenses (in $) of Oman?
Keep it short and to the point. -3.26e+07. In the year 2003, what is the difference between the Expenses (in $) in New Zealand and Expenses (in $) in Oman?
Your answer should be compact. -4.17e+07. In the year 2004, what is the difference between the Expenses (in $) of Belarus and Expenses (in $) of Lesotho?
Ensure brevity in your answer.  1.50e+12. In the year 2004, what is the difference between the Expenses (in $) of Belarus and Expenses (in $) of New Zealand?
Make the answer very short. 1.50e+12. In the year 2004, what is the difference between the Expenses (in $) in Belarus and Expenses (in $) in Oman?
Your answer should be compact. 1.50e+12. In the year 2004, what is the difference between the Expenses (in $) in Lesotho and Expenses (in $) in New Zealand?
Keep it short and to the point. 1.54e+07. In the year 2004, what is the difference between the Expenses (in $) of Lesotho and Expenses (in $) of Oman?
Your response must be concise. -3.13e+07. In the year 2004, what is the difference between the Expenses (in $) in New Zealand and Expenses (in $) in Oman?
Offer a terse response. -4.68e+07. In the year 2005, what is the difference between the Expenses (in $) of Belarus and Expenses (in $) of Lesotho?
Your answer should be compact. 2.29e+12. In the year 2005, what is the difference between the Expenses (in $) of Belarus and Expenses (in $) of New Zealand?
Provide a short and direct response. 2.29e+12. In the year 2005, what is the difference between the Expenses (in $) of Belarus and Expenses (in $) of Oman?
Make the answer very short. 2.29e+12. In the year 2005, what is the difference between the Expenses (in $) of Lesotho and Expenses (in $) of New Zealand?
Give a very brief answer. 4.41e+06. In the year 2005, what is the difference between the Expenses (in $) in Lesotho and Expenses (in $) in Oman?
Provide a short and direct response. -6.45e+07. In the year 2005, what is the difference between the Expenses (in $) in New Zealand and Expenses (in $) in Oman?
Offer a very short reply. -6.89e+07. In the year 2006, what is the difference between the Expenses (in $) in Belarus and Expenses (in $) in Lesotho?
Ensure brevity in your answer.  2.39e+12. In the year 2006, what is the difference between the Expenses (in $) in Belarus and Expenses (in $) in New Zealand?
Offer a very short reply. 2.39e+12. In the year 2006, what is the difference between the Expenses (in $) in Belarus and Expenses (in $) in Oman?
Offer a terse response. 2.39e+12. In the year 2006, what is the difference between the Expenses (in $) in Lesotho and Expenses (in $) in New Zealand?
Keep it short and to the point. 7.18e+07. In the year 2006, what is the difference between the Expenses (in $) in Lesotho and Expenses (in $) in Oman?
Make the answer very short. -3.39e+06. In the year 2006, what is the difference between the Expenses (in $) in New Zealand and Expenses (in $) in Oman?
Your answer should be compact. -7.52e+07. In the year 2007, what is the difference between the Expenses (in $) of Belarus and Expenses (in $) of Lesotho?
Your response must be concise. 1.78e+12. In the year 2007, what is the difference between the Expenses (in $) in Belarus and Expenses (in $) in New Zealand?
Offer a very short reply. 1.78e+12. In the year 2007, what is the difference between the Expenses (in $) of Belarus and Expenses (in $) of Oman?
Give a very brief answer. 1.78e+12. In the year 2007, what is the difference between the Expenses (in $) of Lesotho and Expenses (in $) of New Zealand?
Offer a terse response. 4.62e+06. In the year 2007, what is the difference between the Expenses (in $) of Lesotho and Expenses (in $) of Oman?
Provide a succinct answer. -8.43e+07. In the year 2007, what is the difference between the Expenses (in $) of New Zealand and Expenses (in $) of Oman?
Your response must be concise. -8.89e+07. What is the ratio of the Expenses (in $) of Belarus in 2001 to that in 2002?
Make the answer very short. 0.7. What is the ratio of the Expenses (in $) in Lesotho in 2001 to that in 2002?
Make the answer very short. 0.83. What is the ratio of the Expenses (in $) in New Zealand in 2001 to that in 2002?
Ensure brevity in your answer.  1.37. What is the ratio of the Expenses (in $) in Oman in 2001 to that in 2002?
Make the answer very short. 0.97. What is the ratio of the Expenses (in $) in Belarus in 2001 to that in 2003?
Make the answer very short. 0.14. What is the ratio of the Expenses (in $) in Lesotho in 2001 to that in 2003?
Your answer should be compact. 0.51. What is the ratio of the Expenses (in $) of New Zealand in 2001 to that in 2003?
Provide a succinct answer. 1.33. What is the ratio of the Expenses (in $) in Oman in 2001 to that in 2003?
Make the answer very short. 0.9. What is the ratio of the Expenses (in $) in Belarus in 2001 to that in 2004?
Keep it short and to the point. 0.1. What is the ratio of the Expenses (in $) in Lesotho in 2001 to that in 2004?
Offer a terse response. 0.3. What is the ratio of the Expenses (in $) in New Zealand in 2001 to that in 2004?
Keep it short and to the point. 0.77. What is the ratio of the Expenses (in $) of Oman in 2001 to that in 2004?
Your answer should be compact. 0.79. What is the ratio of the Expenses (in $) in Belarus in 2001 to that in 2005?
Provide a succinct answer. 0.07. What is the ratio of the Expenses (in $) in Lesotho in 2001 to that in 2005?
Provide a short and direct response. 0.79. What is the ratio of the Expenses (in $) in New Zealand in 2001 to that in 2005?
Offer a very short reply. 0.77. What is the ratio of the Expenses (in $) in Oman in 2001 to that in 2005?
Keep it short and to the point. 0.54. What is the ratio of the Expenses (in $) of Belarus in 2001 to that in 2006?
Keep it short and to the point. 0.06. What is the ratio of the Expenses (in $) in Lesotho in 2001 to that in 2006?
Provide a succinct answer. 0.07. What is the ratio of the Expenses (in $) of Oman in 2001 to that in 2006?
Offer a terse response. 0.49. What is the ratio of the Expenses (in $) in Belarus in 2001 to that in 2007?
Offer a very short reply. 0.09. What is the ratio of the Expenses (in $) of Lesotho in 2001 to that in 2007?
Offer a very short reply. 0.8. What is the ratio of the Expenses (in $) of New Zealand in 2001 to that in 2007?
Your response must be concise. 0.9. What is the ratio of the Expenses (in $) of Oman in 2001 to that in 2007?
Make the answer very short. 0.43. What is the ratio of the Expenses (in $) of Belarus in 2002 to that in 2003?
Give a very brief answer. 0.2. What is the ratio of the Expenses (in $) of Lesotho in 2002 to that in 2003?
Make the answer very short. 0.61. What is the ratio of the Expenses (in $) of New Zealand in 2002 to that in 2003?
Your answer should be very brief. 0.97. What is the ratio of the Expenses (in $) in Oman in 2002 to that in 2003?
Make the answer very short. 0.92. What is the ratio of the Expenses (in $) of Belarus in 2002 to that in 2004?
Give a very brief answer. 0.15. What is the ratio of the Expenses (in $) of Lesotho in 2002 to that in 2004?
Keep it short and to the point. 0.36. What is the ratio of the Expenses (in $) of New Zealand in 2002 to that in 2004?
Provide a short and direct response. 0.56. What is the ratio of the Expenses (in $) of Oman in 2002 to that in 2004?
Offer a terse response. 0.81. What is the ratio of the Expenses (in $) of Belarus in 2002 to that in 2005?
Ensure brevity in your answer.  0.1. What is the ratio of the Expenses (in $) of Lesotho in 2002 to that in 2005?
Keep it short and to the point. 0.95. What is the ratio of the Expenses (in $) in New Zealand in 2002 to that in 2005?
Your answer should be very brief. 0.56. What is the ratio of the Expenses (in $) of Oman in 2002 to that in 2005?
Give a very brief answer. 0.56. What is the ratio of the Expenses (in $) in Belarus in 2002 to that in 2006?
Provide a short and direct response. 0.09. What is the ratio of the Expenses (in $) in Lesotho in 2002 to that in 2006?
Ensure brevity in your answer.  0.09. What is the ratio of the Expenses (in $) of New Zealand in 2002 to that in 2006?
Your response must be concise. 0.44. What is the ratio of the Expenses (in $) of Oman in 2002 to that in 2006?
Your response must be concise. 0.51. What is the ratio of the Expenses (in $) of Belarus in 2002 to that in 2007?
Offer a very short reply. 0.12. What is the ratio of the Expenses (in $) in Lesotho in 2002 to that in 2007?
Give a very brief answer. 0.97. What is the ratio of the Expenses (in $) in New Zealand in 2002 to that in 2007?
Your answer should be compact. 0.66. What is the ratio of the Expenses (in $) in Oman in 2002 to that in 2007?
Ensure brevity in your answer.  0.44. What is the ratio of the Expenses (in $) in Belarus in 2003 to that in 2004?
Your response must be concise. 0.75. What is the ratio of the Expenses (in $) of Lesotho in 2003 to that in 2004?
Keep it short and to the point. 0.59. What is the ratio of the Expenses (in $) of New Zealand in 2003 to that in 2004?
Give a very brief answer. 0.58. What is the ratio of the Expenses (in $) in Oman in 2003 to that in 2004?
Ensure brevity in your answer.  0.88. What is the ratio of the Expenses (in $) in Belarus in 2003 to that in 2005?
Give a very brief answer. 0.49. What is the ratio of the Expenses (in $) of Lesotho in 2003 to that in 2005?
Offer a very short reply. 1.56. What is the ratio of the Expenses (in $) of New Zealand in 2003 to that in 2005?
Offer a terse response. 0.58. What is the ratio of the Expenses (in $) in Oman in 2003 to that in 2005?
Make the answer very short. 0.61. What is the ratio of the Expenses (in $) in Belarus in 2003 to that in 2006?
Offer a terse response. 0.47. What is the ratio of the Expenses (in $) of Lesotho in 2003 to that in 2006?
Make the answer very short. 0.14. What is the ratio of the Expenses (in $) of New Zealand in 2003 to that in 2006?
Provide a succinct answer. 0.45. What is the ratio of the Expenses (in $) of Oman in 2003 to that in 2006?
Keep it short and to the point. 0.55. What is the ratio of the Expenses (in $) in Belarus in 2003 to that in 2007?
Offer a very short reply. 0.63. What is the ratio of the Expenses (in $) in Lesotho in 2003 to that in 2007?
Your response must be concise. 1.58. What is the ratio of the Expenses (in $) in New Zealand in 2003 to that in 2007?
Give a very brief answer. 0.68. What is the ratio of the Expenses (in $) in Oman in 2003 to that in 2007?
Give a very brief answer. 0.47. What is the ratio of the Expenses (in $) of Belarus in 2004 to that in 2005?
Offer a terse response. 0.65. What is the ratio of the Expenses (in $) of Lesotho in 2004 to that in 2005?
Make the answer very short. 2.64. What is the ratio of the Expenses (in $) in New Zealand in 2004 to that in 2005?
Ensure brevity in your answer.  1.01. What is the ratio of the Expenses (in $) of Oman in 2004 to that in 2005?
Your answer should be very brief. 0.69. What is the ratio of the Expenses (in $) in Belarus in 2004 to that in 2006?
Your response must be concise. 0.63. What is the ratio of the Expenses (in $) in Lesotho in 2004 to that in 2006?
Your answer should be very brief. 0.24. What is the ratio of the Expenses (in $) of New Zealand in 2004 to that in 2006?
Offer a very short reply. 0.78. What is the ratio of the Expenses (in $) in Oman in 2004 to that in 2006?
Make the answer very short. 0.63. What is the ratio of the Expenses (in $) of Belarus in 2004 to that in 2007?
Ensure brevity in your answer.  0.84. What is the ratio of the Expenses (in $) in Lesotho in 2004 to that in 2007?
Offer a terse response. 2.69. What is the ratio of the Expenses (in $) in New Zealand in 2004 to that in 2007?
Ensure brevity in your answer.  1.17. What is the ratio of the Expenses (in $) of Oman in 2004 to that in 2007?
Keep it short and to the point. 0.54. What is the ratio of the Expenses (in $) in Belarus in 2005 to that in 2006?
Provide a succinct answer. 0.96. What is the ratio of the Expenses (in $) in Lesotho in 2005 to that in 2006?
Your response must be concise. 0.09. What is the ratio of the Expenses (in $) in New Zealand in 2005 to that in 2006?
Give a very brief answer. 0.78. What is the ratio of the Expenses (in $) in Oman in 2005 to that in 2006?
Give a very brief answer. 0.91. What is the ratio of the Expenses (in $) in Belarus in 2005 to that in 2007?
Your answer should be very brief. 1.29. What is the ratio of the Expenses (in $) of Lesotho in 2005 to that in 2007?
Your answer should be very brief. 1.02. What is the ratio of the Expenses (in $) in New Zealand in 2005 to that in 2007?
Provide a short and direct response. 1.16. What is the ratio of the Expenses (in $) in Oman in 2005 to that in 2007?
Offer a very short reply. 0.78. What is the ratio of the Expenses (in $) of Belarus in 2006 to that in 2007?
Offer a very short reply. 1.34. What is the ratio of the Expenses (in $) in Lesotho in 2006 to that in 2007?
Provide a succinct answer. 11.3. What is the ratio of the Expenses (in $) in Oman in 2006 to that in 2007?
Provide a short and direct response. 0.86. What is the difference between the highest and the second highest Expenses (in $) in Belarus?
Give a very brief answer. 1.02e+11. What is the difference between the highest and the second highest Expenses (in $) in Lesotho?
Provide a succinct answer. 5.70e+07. What is the difference between the highest and the second highest Expenses (in $) in New Zealand?
Provide a short and direct response. 6.51e+05. What is the difference between the highest and the second highest Expenses (in $) of Oman?
Your answer should be compact. 1.27e+07. What is the difference between the highest and the lowest Expenses (in $) in Belarus?
Ensure brevity in your answer.  2.24e+12. What is the difference between the highest and the lowest Expenses (in $) in Lesotho?
Your answer should be very brief. 6.95e+07. What is the difference between the highest and the lowest Expenses (in $) in New Zealand?
Make the answer very short. 1.69e+06. What is the difference between the highest and the lowest Expenses (in $) in Oman?
Offer a terse response. 5.22e+07. 